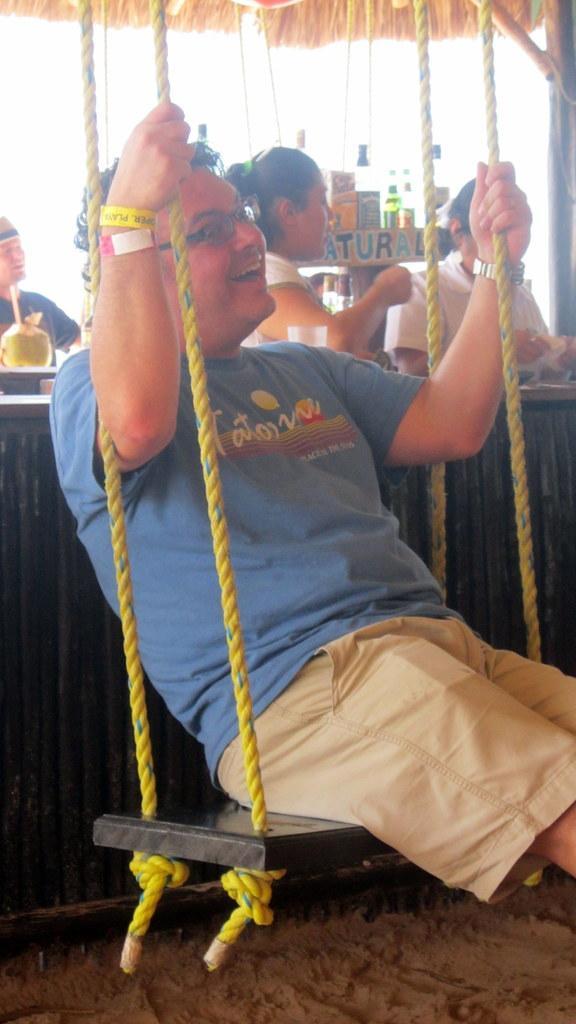In one or two sentences, can you explain what this image depicts? In the picture I can see a man is sitting and holding ropes with hands. In the background I can see people, bottles, a coconut and some other objects. 